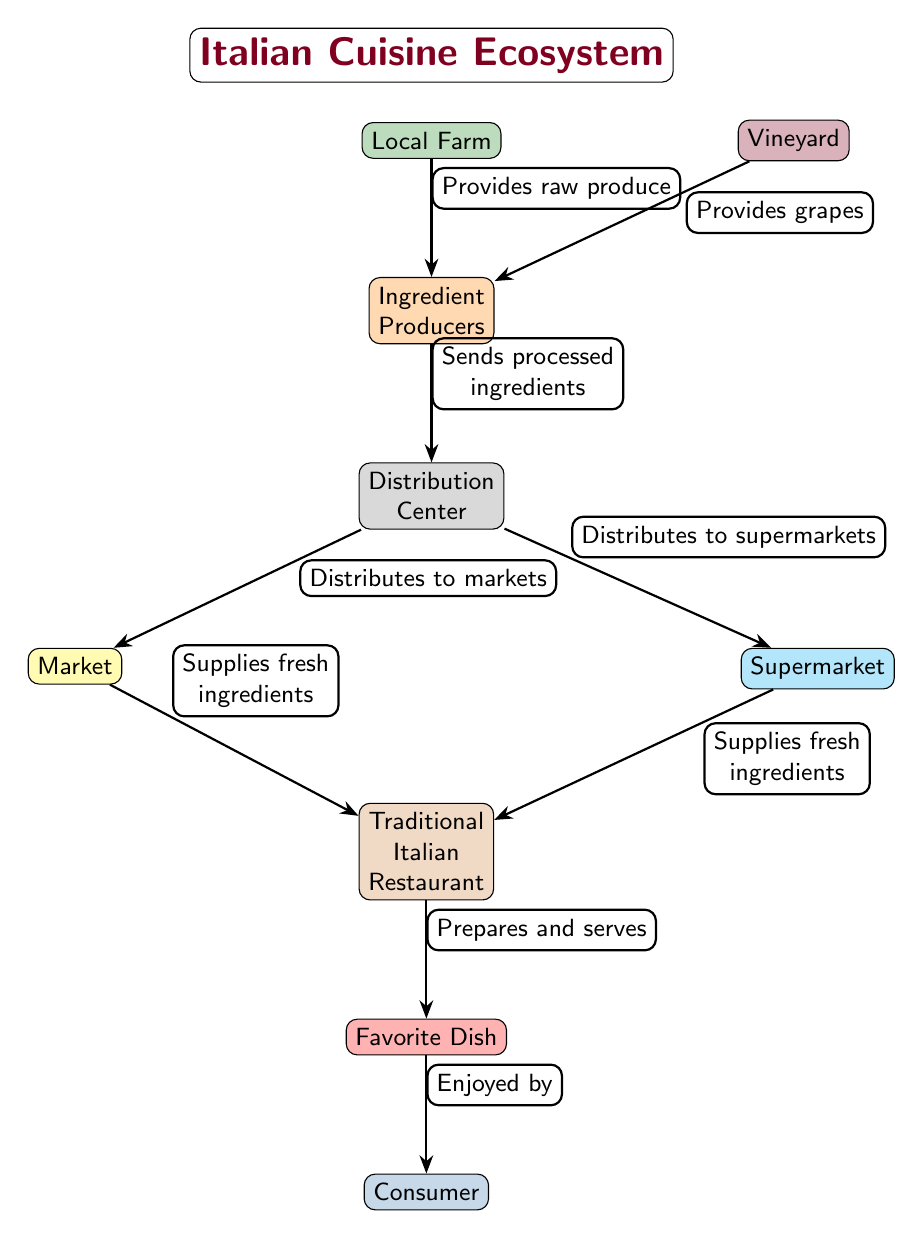What does the Local Farm provide? The Local Farm provides raw produce to the Ingredient Producers as indicated by the edge labeled "Provides raw produce."
Answer: raw produce How many main nodes are present in the diagram? The main nodes include Local Farm, Vineyard, Ingredient Producers, Distribution Center, Market, Supermarket, Traditional Italian Restaurant, Favorite Dish, and Consumer. Counting these gives a total of nine nodes.
Answer: 9 Which node is directly below the Traditional Italian Restaurant? In the diagram, the node directly below the Traditional Italian Restaurant is the Favorite Dish as it proceeds downward as indicated in the diagram.
Answer: Favorite Dish What type of ingredients does the Market supply to the Traditional Italian Restaurant? The Market supplies fresh ingredients to the Traditional Italian Restaurant, as denoted by the edge labeled "Supplies fresh ingredients."
Answer: fresh ingredients What flows from the Ingredient Producers to the Distribution Center? The flow from Ingredient Producers to the Distribution Center consists of processed ingredients, as shown by the edge labeled "Sends processed ingredients."
Answer: processed ingredients What are the two types of suppliers to the Traditional Italian Restaurant? The two types of suppliers to the Traditional Italian Restaurant are the Market and the Supermarket as evident from the edges leading to the Traditional Italian Restaurant.
Answer: Market and Supermarket How does the Consumer interact with the Favorite Dish? The Consumer engages with the Favorite Dish through enjoyment, as indicated by the edge labeled "Enjoyed by."
Answer: Enjoyed by What provides grapes to the Ingredient Producers? The Vineyard provides grapes to the Ingredient Producers, illustrated by the edge labeled "Provides grapes."
Answer: grapes Which node is below the Distribution Center? The nodes below the Distribution Center are the Market and the Supermarket, but the first node directly below is the Market, positioned to the left.
Answer: Market 